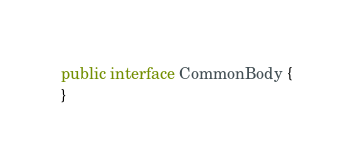Convert code to text. <code><loc_0><loc_0><loc_500><loc_500><_Java_>public interface CommonBody {
}
</code> 